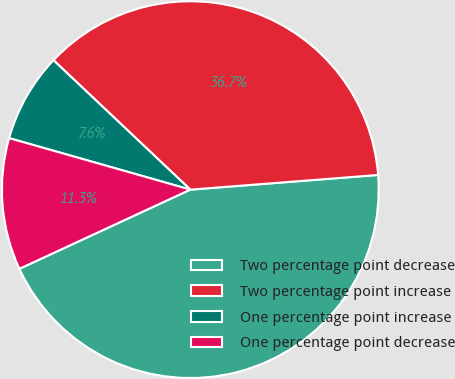Convert chart. <chart><loc_0><loc_0><loc_500><loc_500><pie_chart><fcel>Two percentage point decrease<fcel>Two percentage point increase<fcel>One percentage point increase<fcel>One percentage point decrease<nl><fcel>44.34%<fcel>36.7%<fcel>7.65%<fcel>11.31%<nl></chart> 